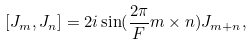Convert formula to latex. <formula><loc_0><loc_0><loc_500><loc_500>[ J _ { m } , J _ { n } ] = 2 i \sin ( { \frac { 2 \pi } { F } } { m \times n } ) J _ { m + n } ,</formula> 